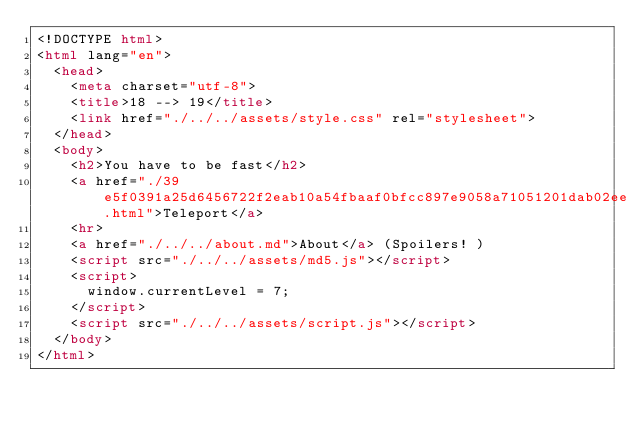<code> <loc_0><loc_0><loc_500><loc_500><_HTML_><!DOCTYPE html>
<html lang="en">
  <head>
    <meta charset="utf-8">
    <title>18 --> 19</title>
    <link href="./../../assets/style.css" rel="stylesheet">
  </head>
  <body>
    <h2>You have to be fast</h2>
    <a href="./39e5f0391a25d6456722f2eab10a54fbaaf0bfcc897e9058a71051201dab02ee.html">Teleport</a>
    <hr>
    <a href="./../../about.md">About</a> (Spoilers! )
    <script src="./../../assets/md5.js"></script>
    <script>
      window.currentLevel = 7;
    </script>
    <script src="./../../assets/script.js"></script>
  </body>
</html></code> 